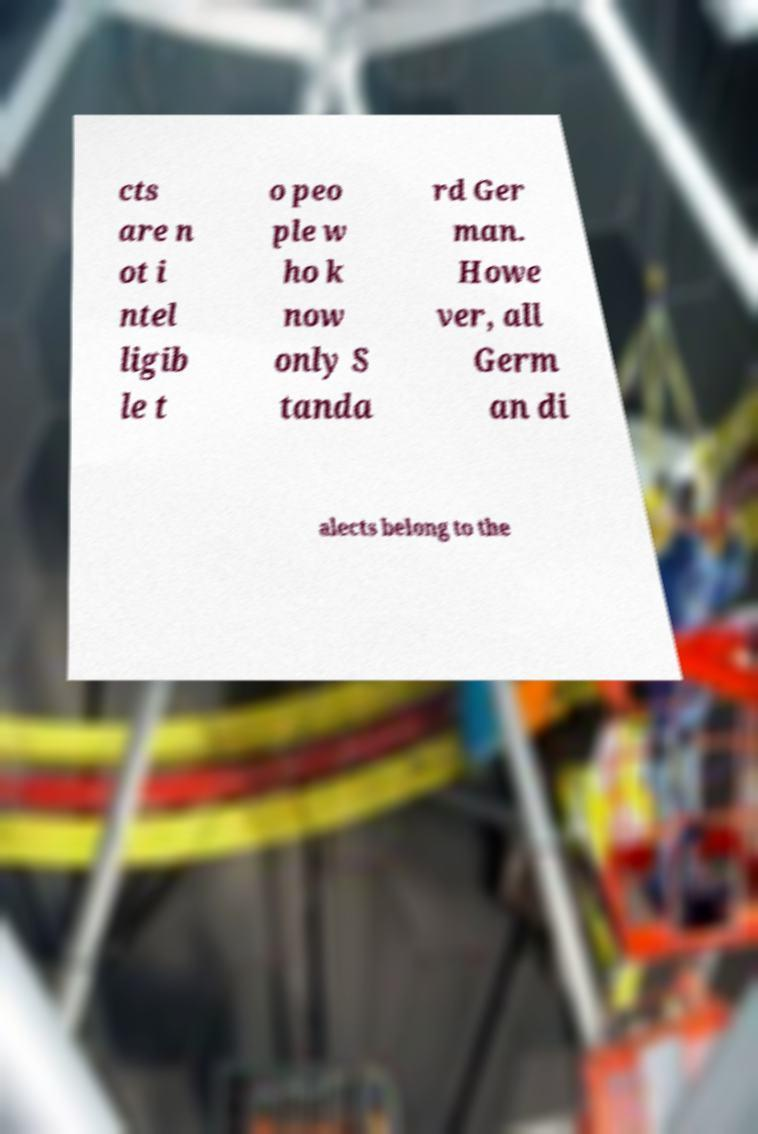There's text embedded in this image that I need extracted. Can you transcribe it verbatim? cts are n ot i ntel ligib le t o peo ple w ho k now only S tanda rd Ger man. Howe ver, all Germ an di alects belong to the 